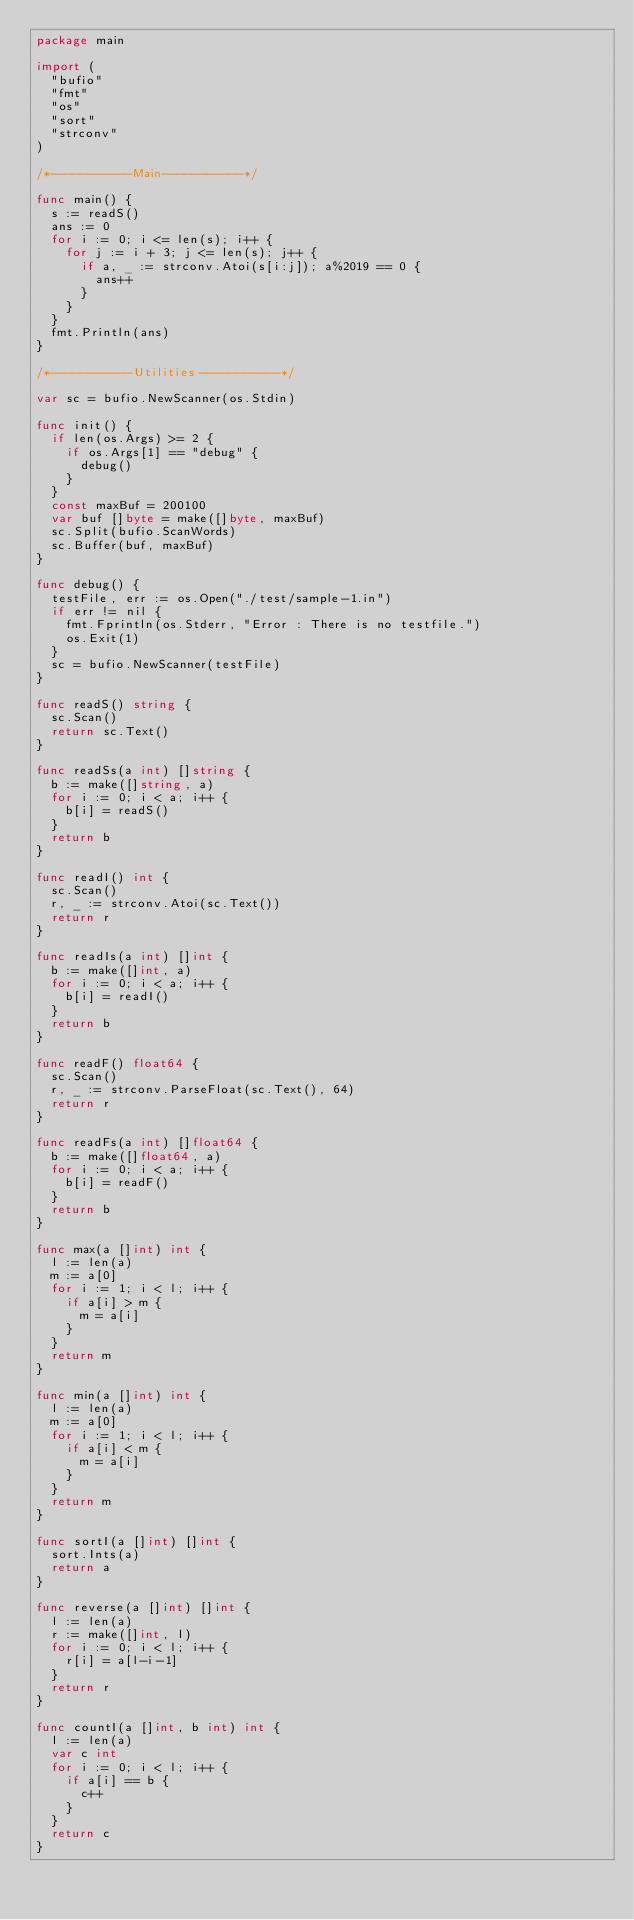<code> <loc_0><loc_0><loc_500><loc_500><_Go_>package main

import (
	"bufio"
	"fmt"
	"os"
	"sort"
	"strconv"
)

/*-----------Main-----------*/

func main() {
	s := readS()
	ans := 0
	for i := 0; i <= len(s); i++ {
		for j := i + 3; j <= len(s); j++ {
			if a, _ := strconv.Atoi(s[i:j]); a%2019 == 0 {
				ans++
			}
		}
	}
	fmt.Println(ans)
}

/*-----------Utilities-----------*/

var sc = bufio.NewScanner(os.Stdin)

func init() {
	if len(os.Args) >= 2 {
		if os.Args[1] == "debug" {
			debug()
		}
	}
	const maxBuf = 200100
	var buf []byte = make([]byte, maxBuf)
	sc.Split(bufio.ScanWords)
	sc.Buffer(buf, maxBuf)
}

func debug() {
	testFile, err := os.Open("./test/sample-1.in")
	if err != nil {
		fmt.Fprintln(os.Stderr, "Error : There is no testfile.")
		os.Exit(1)
	}
	sc = bufio.NewScanner(testFile)
}

func readS() string {
	sc.Scan()
	return sc.Text()
}

func readSs(a int) []string {
	b := make([]string, a)
	for i := 0; i < a; i++ {
		b[i] = readS()
	}
	return b
}

func readI() int {
	sc.Scan()
	r, _ := strconv.Atoi(sc.Text())
	return r
}

func readIs(a int) []int {
	b := make([]int, a)
	for i := 0; i < a; i++ {
		b[i] = readI()
	}
	return b
}

func readF() float64 {
	sc.Scan()
	r, _ := strconv.ParseFloat(sc.Text(), 64)
	return r
}

func readFs(a int) []float64 {
	b := make([]float64, a)
	for i := 0; i < a; i++ {
		b[i] = readF()
	}
	return b
}

func max(a []int) int {
	l := len(a)
	m := a[0]
	for i := 1; i < l; i++ {
		if a[i] > m {
			m = a[i]
		}
	}
	return m
}

func min(a []int) int {
	l := len(a)
	m := a[0]
	for i := 1; i < l; i++ {
		if a[i] < m {
			m = a[i]
		}
	}
	return m
}

func sortI(a []int) []int {
	sort.Ints(a)
	return a
}

func reverse(a []int) []int {
	l := len(a)
	r := make([]int, l)
	for i := 0; i < l; i++ {
		r[i] = a[l-i-1]
	}
	return r
}

func countI(a []int, b int) int {
	l := len(a)
	var c int
	for i := 0; i < l; i++ {
		if a[i] == b {
			c++
		}
	}
	return c
}
</code> 